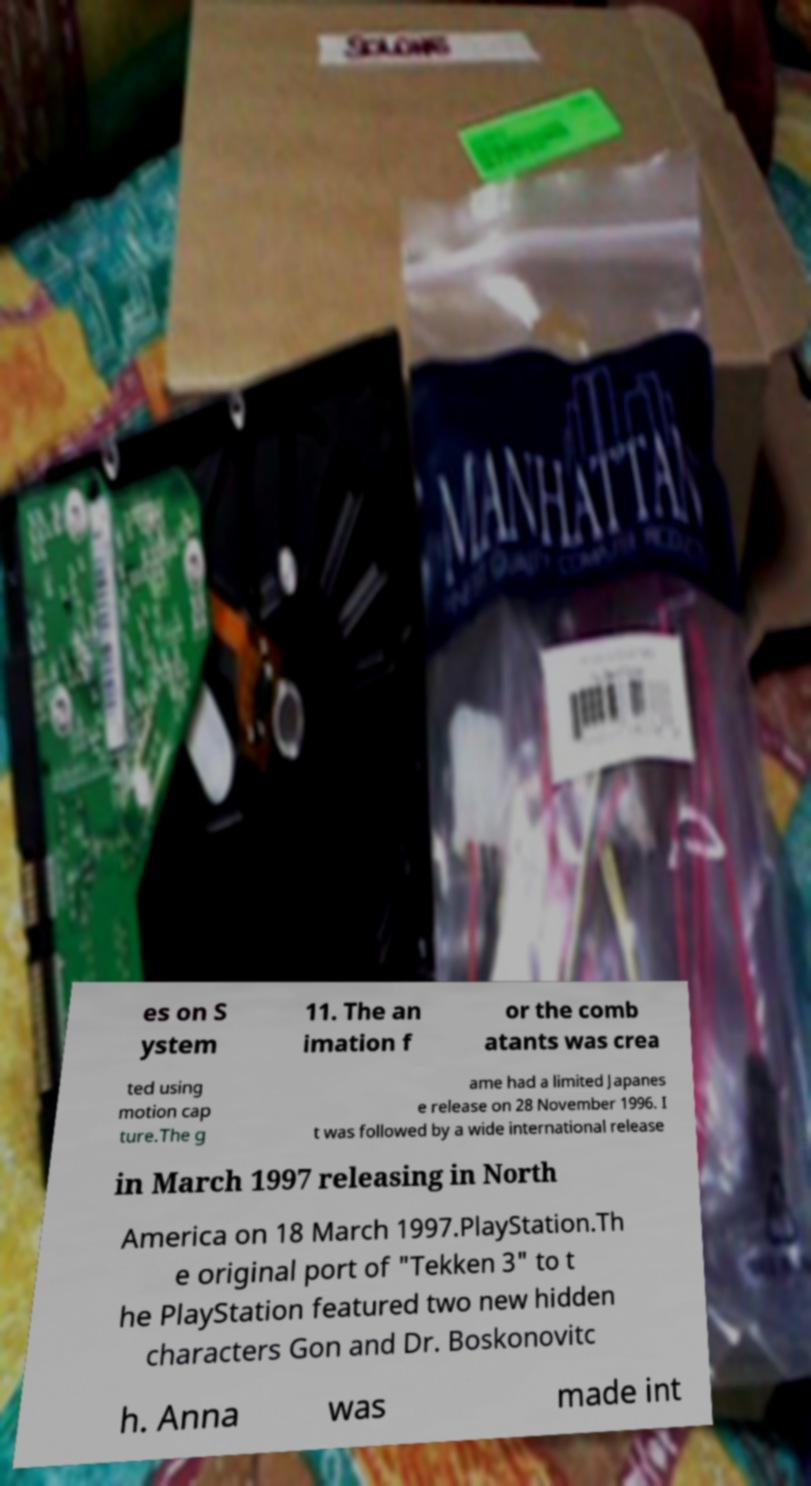Please identify and transcribe the text found in this image. es on S ystem 11. The an imation f or the comb atants was crea ted using motion cap ture.The g ame had a limited Japanes e release on 28 November 1996. I t was followed by a wide international release in March 1997 releasing in North America on 18 March 1997.PlayStation.Th e original port of "Tekken 3" to t he PlayStation featured two new hidden characters Gon and Dr. Boskonovitc h. Anna was made int 